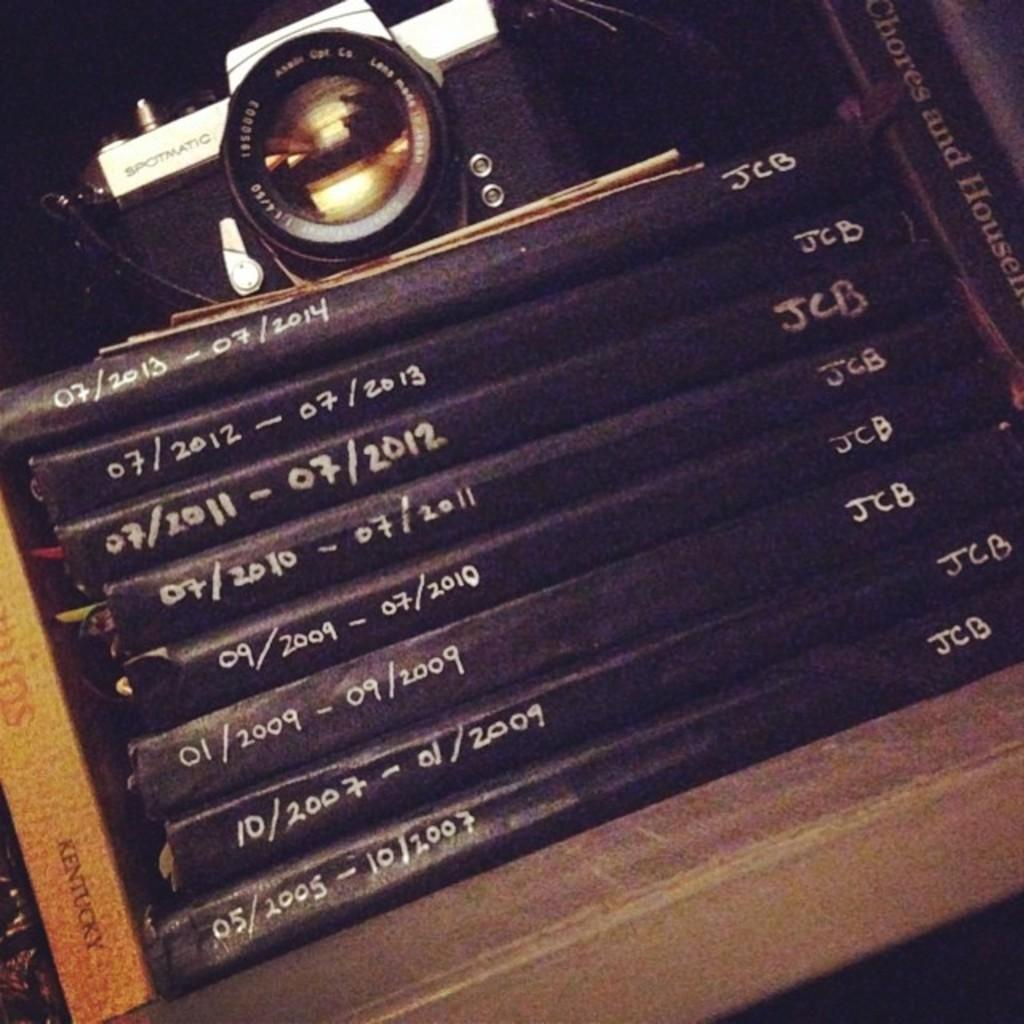Provide a one-sentence caption for the provided image. a set of books marked with dates 5/2005 to 7/2013, JCB initials. 